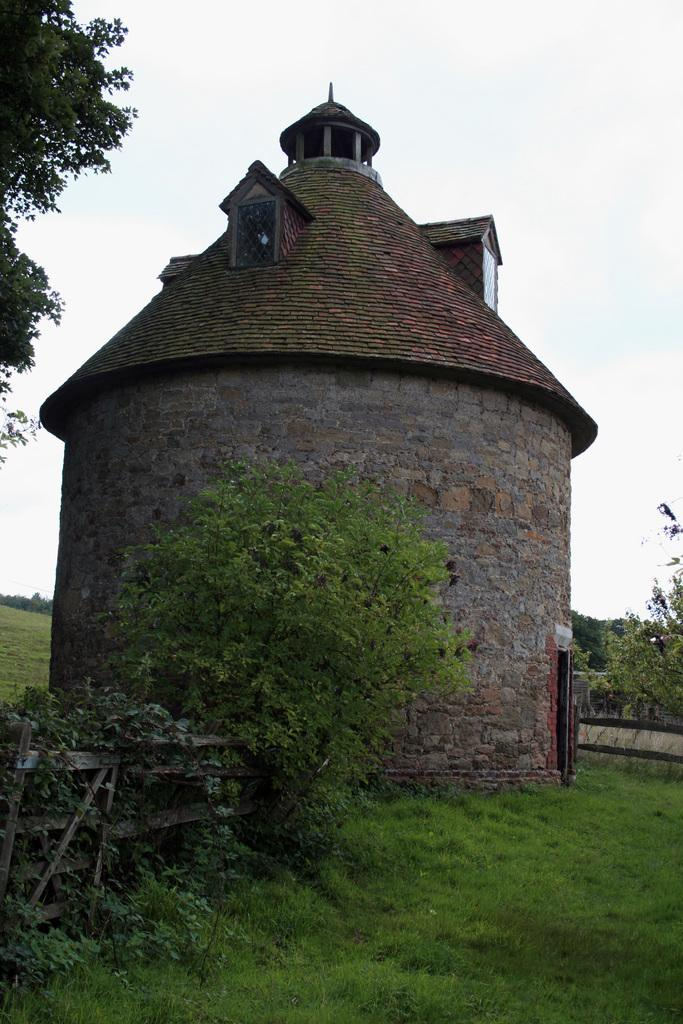What type of structure is present in the image? There is a house in the image. What is the terrain like in the image? There is a grassy land in the image. What type of vegetation can be seen in the image? There are many trees and plants in the image. What part of the natural environment is visible in the image? The sky is visible in the image. What type of reaction can be seen in the image? There is no reaction present in the image; it is a still image of a house, grassy land, trees, plants, and sky. What type of arithmetic problem is being solved in the image? There is no arithmetic problem present in the image; it is a still image of a house, grassy land, trees, plants, and sky. 